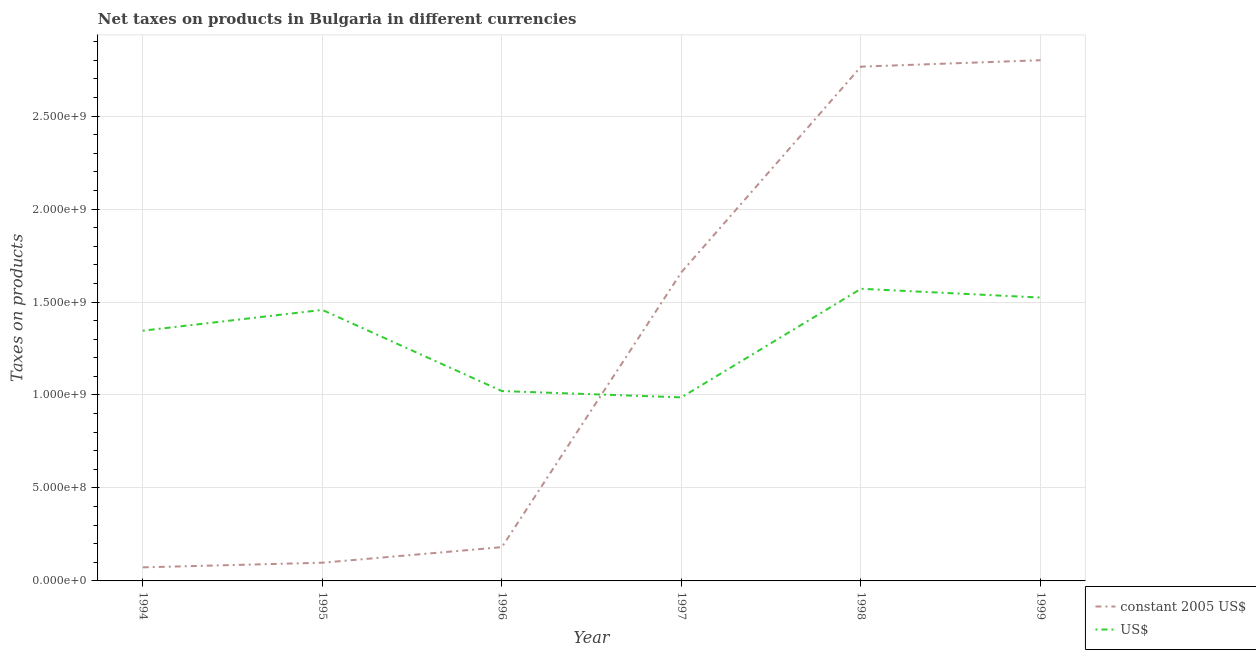How many different coloured lines are there?
Provide a succinct answer. 2. Does the line corresponding to net taxes in us$ intersect with the line corresponding to net taxes in constant 2005 us$?
Provide a succinct answer. Yes. What is the net taxes in us$ in 1995?
Your answer should be compact. 1.46e+09. Across all years, what is the maximum net taxes in us$?
Ensure brevity in your answer.  1.57e+09. Across all years, what is the minimum net taxes in constant 2005 us$?
Provide a short and direct response. 7.29e+07. In which year was the net taxes in us$ minimum?
Your answer should be compact. 1997. What is the total net taxes in constant 2005 us$ in the graph?
Provide a succinct answer. 7.58e+09. What is the difference between the net taxes in constant 2005 us$ in 1994 and that in 1997?
Make the answer very short. -1.59e+09. What is the difference between the net taxes in us$ in 1994 and the net taxes in constant 2005 us$ in 1997?
Give a very brief answer. -3.15e+08. What is the average net taxes in constant 2005 us$ per year?
Your answer should be very brief. 1.26e+09. In the year 1996, what is the difference between the net taxes in constant 2005 us$ and net taxes in us$?
Make the answer very short. -8.39e+08. What is the ratio of the net taxes in constant 2005 us$ in 1996 to that in 1998?
Your response must be concise. 0.07. Is the net taxes in constant 2005 us$ in 1997 less than that in 1999?
Offer a very short reply. Yes. What is the difference between the highest and the second highest net taxes in us$?
Make the answer very short. 4.73e+07. What is the difference between the highest and the lowest net taxes in us$?
Ensure brevity in your answer.  5.84e+08. Is the sum of the net taxes in us$ in 1997 and 1998 greater than the maximum net taxes in constant 2005 us$ across all years?
Make the answer very short. No. Does the net taxes in us$ monotonically increase over the years?
Offer a very short reply. No. Is the net taxes in constant 2005 us$ strictly less than the net taxes in us$ over the years?
Make the answer very short. No. How many lines are there?
Your response must be concise. 2. How many years are there in the graph?
Your response must be concise. 6. What is the difference between two consecutive major ticks on the Y-axis?
Give a very brief answer. 5.00e+08. Where does the legend appear in the graph?
Provide a succinct answer. Bottom right. What is the title of the graph?
Your answer should be compact. Net taxes on products in Bulgaria in different currencies. Does "Female entrants" appear as one of the legend labels in the graph?
Your answer should be very brief. No. What is the label or title of the X-axis?
Your answer should be compact. Year. What is the label or title of the Y-axis?
Give a very brief answer. Taxes on products. What is the Taxes on products in constant 2005 US$ in 1994?
Offer a terse response. 7.29e+07. What is the Taxes on products in US$ in 1994?
Keep it short and to the point. 1.35e+09. What is the Taxes on products in constant 2005 US$ in 1995?
Ensure brevity in your answer.  9.79e+07. What is the Taxes on products of US$ in 1995?
Make the answer very short. 1.46e+09. What is the Taxes on products of constant 2005 US$ in 1996?
Offer a very short reply. 1.82e+08. What is the Taxes on products in US$ in 1996?
Provide a short and direct response. 1.02e+09. What is the Taxes on products of constant 2005 US$ in 1997?
Give a very brief answer. 1.66e+09. What is the Taxes on products of US$ in 1997?
Ensure brevity in your answer.  9.87e+08. What is the Taxes on products of constant 2005 US$ in 1998?
Give a very brief answer. 2.77e+09. What is the Taxes on products of US$ in 1998?
Give a very brief answer. 1.57e+09. What is the Taxes on products in constant 2005 US$ in 1999?
Keep it short and to the point. 2.80e+09. What is the Taxes on products of US$ in 1999?
Keep it short and to the point. 1.52e+09. Across all years, what is the maximum Taxes on products in constant 2005 US$?
Provide a short and direct response. 2.80e+09. Across all years, what is the maximum Taxes on products of US$?
Give a very brief answer. 1.57e+09. Across all years, what is the minimum Taxes on products of constant 2005 US$?
Provide a short and direct response. 7.29e+07. Across all years, what is the minimum Taxes on products in US$?
Your answer should be very brief. 9.87e+08. What is the total Taxes on products of constant 2005 US$ in the graph?
Provide a succinct answer. 7.58e+09. What is the total Taxes on products of US$ in the graph?
Make the answer very short. 7.91e+09. What is the difference between the Taxes on products in constant 2005 US$ in 1994 and that in 1995?
Give a very brief answer. -2.50e+07. What is the difference between the Taxes on products in US$ in 1994 and that in 1995?
Your answer should be very brief. -1.12e+08. What is the difference between the Taxes on products in constant 2005 US$ in 1994 and that in 1996?
Your answer should be compact. -1.09e+08. What is the difference between the Taxes on products of US$ in 1994 and that in 1996?
Offer a terse response. 3.25e+08. What is the difference between the Taxes on products in constant 2005 US$ in 1994 and that in 1997?
Your answer should be very brief. -1.59e+09. What is the difference between the Taxes on products in US$ in 1994 and that in 1997?
Offer a very short reply. 3.59e+08. What is the difference between the Taxes on products in constant 2005 US$ in 1994 and that in 1998?
Give a very brief answer. -2.69e+09. What is the difference between the Taxes on products of US$ in 1994 and that in 1998?
Offer a very short reply. -2.25e+08. What is the difference between the Taxes on products in constant 2005 US$ in 1994 and that in 1999?
Ensure brevity in your answer.  -2.73e+09. What is the difference between the Taxes on products in US$ in 1994 and that in 1999?
Ensure brevity in your answer.  -1.78e+08. What is the difference between the Taxes on products in constant 2005 US$ in 1995 and that in 1996?
Keep it short and to the point. -8.37e+07. What is the difference between the Taxes on products of US$ in 1995 and that in 1996?
Your response must be concise. 4.36e+08. What is the difference between the Taxes on products in constant 2005 US$ in 1995 and that in 1997?
Provide a short and direct response. -1.56e+09. What is the difference between the Taxes on products in US$ in 1995 and that in 1997?
Your response must be concise. 4.70e+08. What is the difference between the Taxes on products in constant 2005 US$ in 1995 and that in 1998?
Keep it short and to the point. -2.67e+09. What is the difference between the Taxes on products in US$ in 1995 and that in 1998?
Give a very brief answer. -1.14e+08. What is the difference between the Taxes on products in constant 2005 US$ in 1995 and that in 1999?
Provide a succinct answer. -2.70e+09. What is the difference between the Taxes on products in US$ in 1995 and that in 1999?
Give a very brief answer. -6.63e+07. What is the difference between the Taxes on products of constant 2005 US$ in 1996 and that in 1997?
Keep it short and to the point. -1.48e+09. What is the difference between the Taxes on products in US$ in 1996 and that in 1997?
Offer a terse response. 3.38e+07. What is the difference between the Taxes on products of constant 2005 US$ in 1996 and that in 1998?
Offer a very short reply. -2.58e+09. What is the difference between the Taxes on products of US$ in 1996 and that in 1998?
Your answer should be compact. -5.50e+08. What is the difference between the Taxes on products in constant 2005 US$ in 1996 and that in 1999?
Provide a short and direct response. -2.62e+09. What is the difference between the Taxes on products in US$ in 1996 and that in 1999?
Provide a short and direct response. -5.03e+08. What is the difference between the Taxes on products of constant 2005 US$ in 1997 and that in 1998?
Your response must be concise. -1.11e+09. What is the difference between the Taxes on products of US$ in 1997 and that in 1998?
Provide a short and direct response. -5.84e+08. What is the difference between the Taxes on products of constant 2005 US$ in 1997 and that in 1999?
Offer a terse response. -1.14e+09. What is the difference between the Taxes on products of US$ in 1997 and that in 1999?
Ensure brevity in your answer.  -5.37e+08. What is the difference between the Taxes on products in constant 2005 US$ in 1998 and that in 1999?
Ensure brevity in your answer.  -3.45e+07. What is the difference between the Taxes on products in US$ in 1998 and that in 1999?
Your answer should be compact. 4.73e+07. What is the difference between the Taxes on products in constant 2005 US$ in 1994 and the Taxes on products in US$ in 1995?
Your answer should be compact. -1.38e+09. What is the difference between the Taxes on products of constant 2005 US$ in 1994 and the Taxes on products of US$ in 1996?
Your answer should be very brief. -9.48e+08. What is the difference between the Taxes on products of constant 2005 US$ in 1994 and the Taxes on products of US$ in 1997?
Offer a terse response. -9.14e+08. What is the difference between the Taxes on products in constant 2005 US$ in 1994 and the Taxes on products in US$ in 1998?
Ensure brevity in your answer.  -1.50e+09. What is the difference between the Taxes on products of constant 2005 US$ in 1994 and the Taxes on products of US$ in 1999?
Provide a short and direct response. -1.45e+09. What is the difference between the Taxes on products in constant 2005 US$ in 1995 and the Taxes on products in US$ in 1996?
Your answer should be compact. -9.23e+08. What is the difference between the Taxes on products in constant 2005 US$ in 1995 and the Taxes on products in US$ in 1997?
Provide a short and direct response. -8.89e+08. What is the difference between the Taxes on products of constant 2005 US$ in 1995 and the Taxes on products of US$ in 1998?
Give a very brief answer. -1.47e+09. What is the difference between the Taxes on products in constant 2005 US$ in 1995 and the Taxes on products in US$ in 1999?
Your answer should be compact. -1.43e+09. What is the difference between the Taxes on products of constant 2005 US$ in 1996 and the Taxes on products of US$ in 1997?
Ensure brevity in your answer.  -8.06e+08. What is the difference between the Taxes on products in constant 2005 US$ in 1996 and the Taxes on products in US$ in 1998?
Keep it short and to the point. -1.39e+09. What is the difference between the Taxes on products of constant 2005 US$ in 1996 and the Taxes on products of US$ in 1999?
Give a very brief answer. -1.34e+09. What is the difference between the Taxes on products in constant 2005 US$ in 1997 and the Taxes on products in US$ in 1998?
Offer a terse response. 8.92e+07. What is the difference between the Taxes on products in constant 2005 US$ in 1997 and the Taxes on products in US$ in 1999?
Your response must be concise. 1.37e+08. What is the difference between the Taxes on products in constant 2005 US$ in 1998 and the Taxes on products in US$ in 1999?
Ensure brevity in your answer.  1.24e+09. What is the average Taxes on products of constant 2005 US$ per year?
Offer a terse response. 1.26e+09. What is the average Taxes on products in US$ per year?
Provide a succinct answer. 1.32e+09. In the year 1994, what is the difference between the Taxes on products of constant 2005 US$ and Taxes on products of US$?
Give a very brief answer. -1.27e+09. In the year 1995, what is the difference between the Taxes on products in constant 2005 US$ and Taxes on products in US$?
Offer a terse response. -1.36e+09. In the year 1996, what is the difference between the Taxes on products of constant 2005 US$ and Taxes on products of US$?
Make the answer very short. -8.39e+08. In the year 1997, what is the difference between the Taxes on products of constant 2005 US$ and Taxes on products of US$?
Offer a very short reply. 6.73e+08. In the year 1998, what is the difference between the Taxes on products in constant 2005 US$ and Taxes on products in US$?
Make the answer very short. 1.19e+09. In the year 1999, what is the difference between the Taxes on products of constant 2005 US$ and Taxes on products of US$?
Keep it short and to the point. 1.28e+09. What is the ratio of the Taxes on products of constant 2005 US$ in 1994 to that in 1995?
Give a very brief answer. 0.74. What is the ratio of the Taxes on products in US$ in 1994 to that in 1995?
Make the answer very short. 0.92. What is the ratio of the Taxes on products in constant 2005 US$ in 1994 to that in 1996?
Your answer should be very brief. 0.4. What is the ratio of the Taxes on products of US$ in 1994 to that in 1996?
Keep it short and to the point. 1.32. What is the ratio of the Taxes on products in constant 2005 US$ in 1994 to that in 1997?
Make the answer very short. 0.04. What is the ratio of the Taxes on products in US$ in 1994 to that in 1997?
Offer a very short reply. 1.36. What is the ratio of the Taxes on products in constant 2005 US$ in 1994 to that in 1998?
Your response must be concise. 0.03. What is the ratio of the Taxes on products in US$ in 1994 to that in 1998?
Provide a succinct answer. 0.86. What is the ratio of the Taxes on products in constant 2005 US$ in 1994 to that in 1999?
Make the answer very short. 0.03. What is the ratio of the Taxes on products in US$ in 1994 to that in 1999?
Your answer should be compact. 0.88. What is the ratio of the Taxes on products of constant 2005 US$ in 1995 to that in 1996?
Ensure brevity in your answer.  0.54. What is the ratio of the Taxes on products in US$ in 1995 to that in 1996?
Give a very brief answer. 1.43. What is the ratio of the Taxes on products of constant 2005 US$ in 1995 to that in 1997?
Offer a very short reply. 0.06. What is the ratio of the Taxes on products of US$ in 1995 to that in 1997?
Provide a succinct answer. 1.48. What is the ratio of the Taxes on products of constant 2005 US$ in 1995 to that in 1998?
Your answer should be compact. 0.04. What is the ratio of the Taxes on products of US$ in 1995 to that in 1998?
Provide a succinct answer. 0.93. What is the ratio of the Taxes on products in constant 2005 US$ in 1995 to that in 1999?
Your answer should be very brief. 0.04. What is the ratio of the Taxes on products in US$ in 1995 to that in 1999?
Offer a very short reply. 0.96. What is the ratio of the Taxes on products of constant 2005 US$ in 1996 to that in 1997?
Offer a terse response. 0.11. What is the ratio of the Taxes on products in US$ in 1996 to that in 1997?
Make the answer very short. 1.03. What is the ratio of the Taxes on products in constant 2005 US$ in 1996 to that in 1998?
Ensure brevity in your answer.  0.07. What is the ratio of the Taxes on products in US$ in 1996 to that in 1998?
Make the answer very short. 0.65. What is the ratio of the Taxes on products of constant 2005 US$ in 1996 to that in 1999?
Your answer should be very brief. 0.06. What is the ratio of the Taxes on products of US$ in 1996 to that in 1999?
Your answer should be very brief. 0.67. What is the ratio of the Taxes on products of constant 2005 US$ in 1997 to that in 1998?
Make the answer very short. 0.6. What is the ratio of the Taxes on products of US$ in 1997 to that in 1998?
Keep it short and to the point. 0.63. What is the ratio of the Taxes on products in constant 2005 US$ in 1997 to that in 1999?
Your response must be concise. 0.59. What is the ratio of the Taxes on products of US$ in 1997 to that in 1999?
Provide a short and direct response. 0.65. What is the ratio of the Taxes on products of constant 2005 US$ in 1998 to that in 1999?
Provide a succinct answer. 0.99. What is the ratio of the Taxes on products of US$ in 1998 to that in 1999?
Your response must be concise. 1.03. What is the difference between the highest and the second highest Taxes on products of constant 2005 US$?
Give a very brief answer. 3.45e+07. What is the difference between the highest and the second highest Taxes on products in US$?
Keep it short and to the point. 4.73e+07. What is the difference between the highest and the lowest Taxes on products in constant 2005 US$?
Your response must be concise. 2.73e+09. What is the difference between the highest and the lowest Taxes on products in US$?
Give a very brief answer. 5.84e+08. 